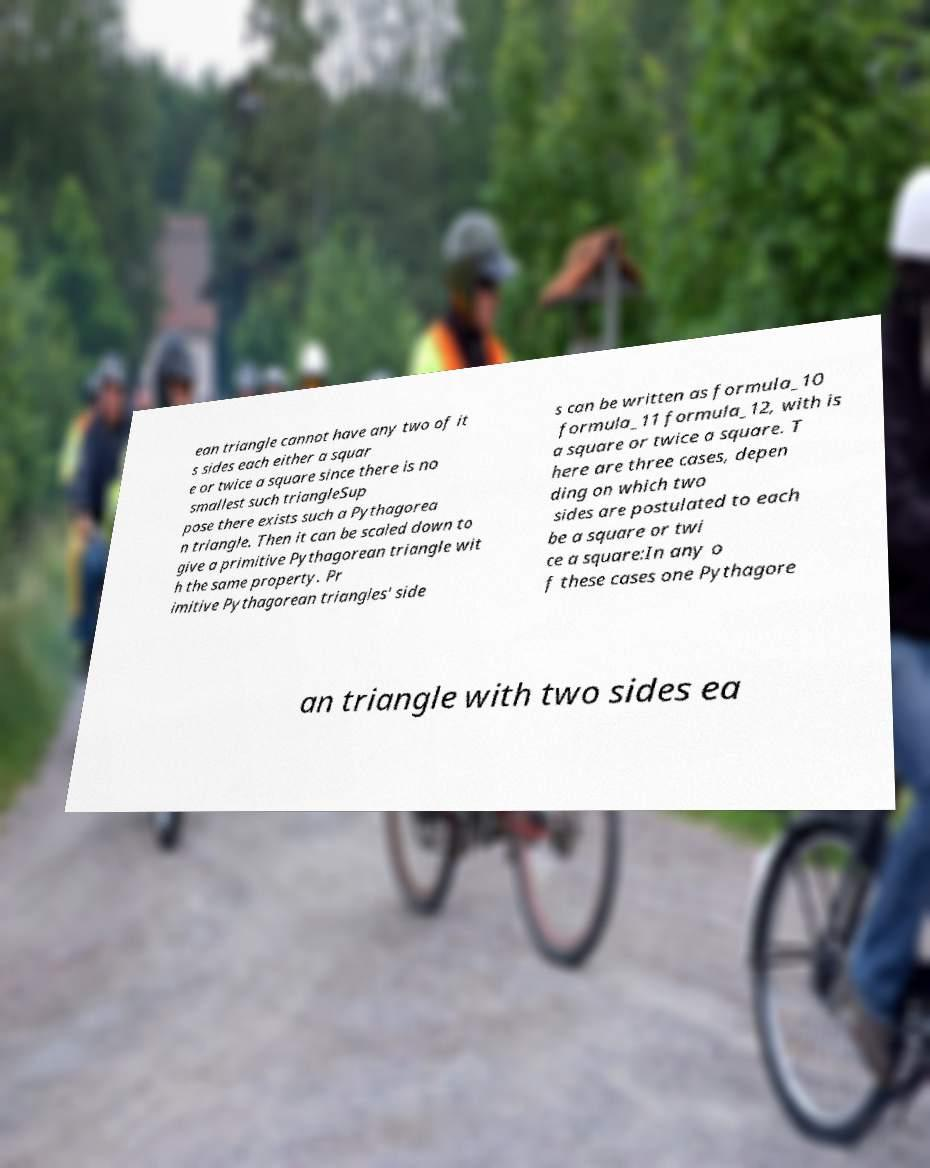Please identify and transcribe the text found in this image. ean triangle cannot have any two of it s sides each either a squar e or twice a square since there is no smallest such triangleSup pose there exists such a Pythagorea n triangle. Then it can be scaled down to give a primitive Pythagorean triangle wit h the same property. Pr imitive Pythagorean triangles' side s can be written as formula_10 formula_11 formula_12, with is a square or twice a square. T here are three cases, depen ding on which two sides are postulated to each be a square or twi ce a square:In any o f these cases one Pythagore an triangle with two sides ea 